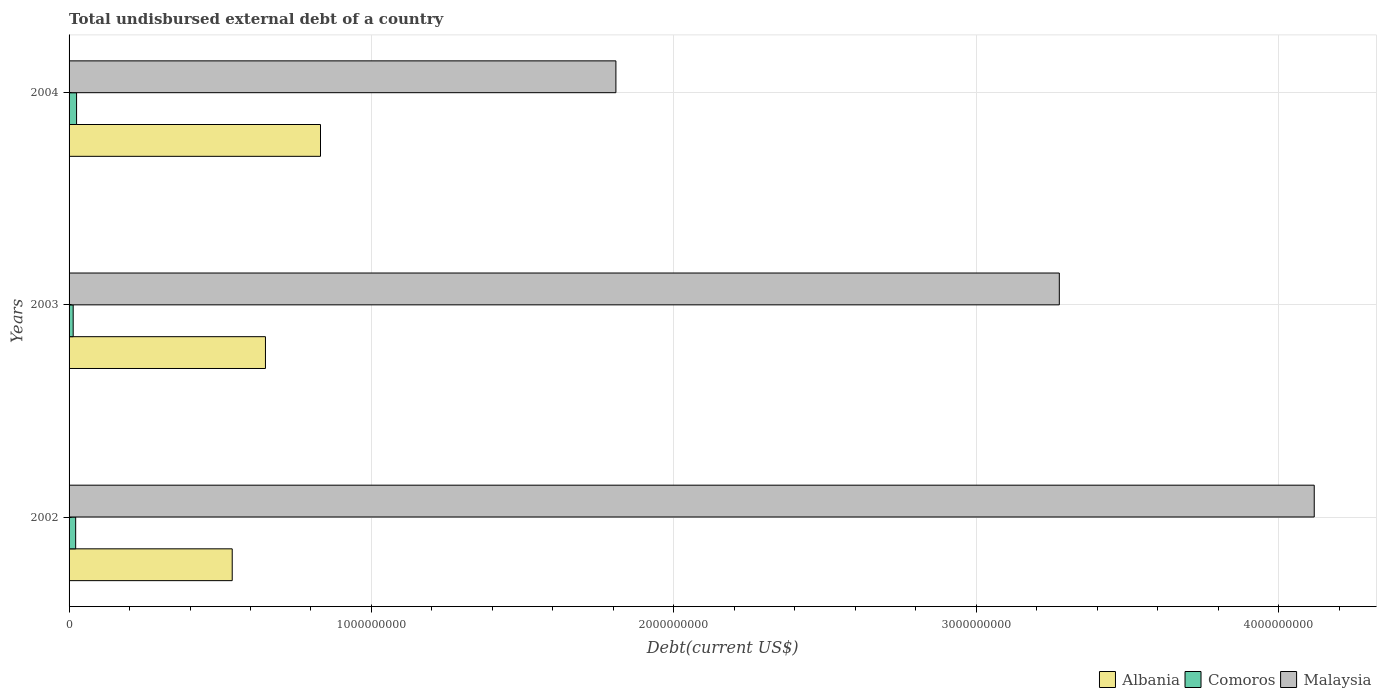How many different coloured bars are there?
Your answer should be very brief. 3. Are the number of bars on each tick of the Y-axis equal?
Your answer should be compact. Yes. How many bars are there on the 3rd tick from the top?
Make the answer very short. 3. How many bars are there on the 2nd tick from the bottom?
Give a very brief answer. 3. What is the total undisbursed external debt in Malaysia in 2002?
Your response must be concise. 4.12e+09. Across all years, what is the maximum total undisbursed external debt in Albania?
Provide a succinct answer. 8.31e+08. Across all years, what is the minimum total undisbursed external debt in Comoros?
Offer a very short reply. 1.36e+07. In which year was the total undisbursed external debt in Malaysia maximum?
Give a very brief answer. 2002. What is the total total undisbursed external debt in Albania in the graph?
Provide a succinct answer. 2.02e+09. What is the difference between the total undisbursed external debt in Comoros in 2003 and that in 2004?
Offer a very short reply. -1.12e+07. What is the difference between the total undisbursed external debt in Comoros in 2004 and the total undisbursed external debt in Malaysia in 2002?
Offer a terse response. -4.09e+09. What is the average total undisbursed external debt in Malaysia per year?
Your response must be concise. 3.07e+09. In the year 2003, what is the difference between the total undisbursed external debt in Malaysia and total undisbursed external debt in Comoros?
Offer a terse response. 3.26e+09. In how many years, is the total undisbursed external debt in Malaysia greater than 2800000000 US$?
Give a very brief answer. 2. What is the ratio of the total undisbursed external debt in Comoros in 2003 to that in 2004?
Provide a short and direct response. 0.55. Is the difference between the total undisbursed external debt in Malaysia in 2002 and 2003 greater than the difference between the total undisbursed external debt in Comoros in 2002 and 2003?
Give a very brief answer. Yes. What is the difference between the highest and the second highest total undisbursed external debt in Comoros?
Give a very brief answer. 3.01e+06. What is the difference between the highest and the lowest total undisbursed external debt in Comoros?
Keep it short and to the point. 1.12e+07. In how many years, is the total undisbursed external debt in Albania greater than the average total undisbursed external debt in Albania taken over all years?
Your response must be concise. 1. What does the 2nd bar from the top in 2003 represents?
Keep it short and to the point. Comoros. What does the 1st bar from the bottom in 2004 represents?
Provide a succinct answer. Albania. How many bars are there?
Provide a short and direct response. 9. Are all the bars in the graph horizontal?
Offer a terse response. Yes. How many years are there in the graph?
Give a very brief answer. 3. What is the difference between two consecutive major ticks on the X-axis?
Offer a terse response. 1.00e+09. Are the values on the major ticks of X-axis written in scientific E-notation?
Provide a short and direct response. No. Does the graph contain grids?
Make the answer very short. Yes. Where does the legend appear in the graph?
Your answer should be compact. Bottom right. What is the title of the graph?
Provide a succinct answer. Total undisbursed external debt of a country. What is the label or title of the X-axis?
Provide a succinct answer. Debt(current US$). What is the Debt(current US$) in Albania in 2002?
Your answer should be very brief. 5.40e+08. What is the Debt(current US$) of Comoros in 2002?
Ensure brevity in your answer.  2.18e+07. What is the Debt(current US$) of Malaysia in 2002?
Ensure brevity in your answer.  4.12e+09. What is the Debt(current US$) of Albania in 2003?
Give a very brief answer. 6.49e+08. What is the Debt(current US$) in Comoros in 2003?
Ensure brevity in your answer.  1.36e+07. What is the Debt(current US$) in Malaysia in 2003?
Your answer should be compact. 3.27e+09. What is the Debt(current US$) in Albania in 2004?
Offer a very short reply. 8.31e+08. What is the Debt(current US$) of Comoros in 2004?
Offer a very short reply. 2.48e+07. What is the Debt(current US$) of Malaysia in 2004?
Offer a very short reply. 1.81e+09. Across all years, what is the maximum Debt(current US$) in Albania?
Your response must be concise. 8.31e+08. Across all years, what is the maximum Debt(current US$) in Comoros?
Your answer should be very brief. 2.48e+07. Across all years, what is the maximum Debt(current US$) in Malaysia?
Make the answer very short. 4.12e+09. Across all years, what is the minimum Debt(current US$) of Albania?
Your response must be concise. 5.40e+08. Across all years, what is the minimum Debt(current US$) in Comoros?
Your answer should be very brief. 1.36e+07. Across all years, what is the minimum Debt(current US$) of Malaysia?
Your answer should be very brief. 1.81e+09. What is the total Debt(current US$) of Albania in the graph?
Provide a short and direct response. 2.02e+09. What is the total Debt(current US$) of Comoros in the graph?
Keep it short and to the point. 6.03e+07. What is the total Debt(current US$) in Malaysia in the graph?
Your answer should be very brief. 9.20e+09. What is the difference between the Debt(current US$) in Albania in 2002 and that in 2003?
Provide a succinct answer. -1.10e+08. What is the difference between the Debt(current US$) of Comoros in 2002 and that in 2003?
Your answer should be compact. 8.18e+06. What is the difference between the Debt(current US$) of Malaysia in 2002 and that in 2003?
Offer a terse response. 8.43e+08. What is the difference between the Debt(current US$) in Albania in 2002 and that in 2004?
Provide a succinct answer. -2.92e+08. What is the difference between the Debt(current US$) of Comoros in 2002 and that in 2004?
Make the answer very short. -3.01e+06. What is the difference between the Debt(current US$) of Malaysia in 2002 and that in 2004?
Your response must be concise. 2.31e+09. What is the difference between the Debt(current US$) of Albania in 2003 and that in 2004?
Provide a short and direct response. -1.82e+08. What is the difference between the Debt(current US$) in Comoros in 2003 and that in 2004?
Make the answer very short. -1.12e+07. What is the difference between the Debt(current US$) of Malaysia in 2003 and that in 2004?
Give a very brief answer. 1.47e+09. What is the difference between the Debt(current US$) in Albania in 2002 and the Debt(current US$) in Comoros in 2003?
Offer a very short reply. 5.26e+08. What is the difference between the Debt(current US$) of Albania in 2002 and the Debt(current US$) of Malaysia in 2003?
Offer a terse response. -2.74e+09. What is the difference between the Debt(current US$) in Comoros in 2002 and the Debt(current US$) in Malaysia in 2003?
Keep it short and to the point. -3.25e+09. What is the difference between the Debt(current US$) of Albania in 2002 and the Debt(current US$) of Comoros in 2004?
Ensure brevity in your answer.  5.15e+08. What is the difference between the Debt(current US$) in Albania in 2002 and the Debt(current US$) in Malaysia in 2004?
Offer a very short reply. -1.27e+09. What is the difference between the Debt(current US$) of Comoros in 2002 and the Debt(current US$) of Malaysia in 2004?
Ensure brevity in your answer.  -1.79e+09. What is the difference between the Debt(current US$) in Albania in 2003 and the Debt(current US$) in Comoros in 2004?
Provide a succinct answer. 6.25e+08. What is the difference between the Debt(current US$) in Albania in 2003 and the Debt(current US$) in Malaysia in 2004?
Provide a succinct answer. -1.16e+09. What is the difference between the Debt(current US$) in Comoros in 2003 and the Debt(current US$) in Malaysia in 2004?
Provide a short and direct response. -1.79e+09. What is the average Debt(current US$) in Albania per year?
Keep it short and to the point. 6.73e+08. What is the average Debt(current US$) in Comoros per year?
Your response must be concise. 2.01e+07. What is the average Debt(current US$) in Malaysia per year?
Make the answer very short. 3.07e+09. In the year 2002, what is the difference between the Debt(current US$) of Albania and Debt(current US$) of Comoros?
Offer a very short reply. 5.18e+08. In the year 2002, what is the difference between the Debt(current US$) in Albania and Debt(current US$) in Malaysia?
Your answer should be very brief. -3.58e+09. In the year 2002, what is the difference between the Debt(current US$) of Comoros and Debt(current US$) of Malaysia?
Your response must be concise. -4.10e+09. In the year 2003, what is the difference between the Debt(current US$) of Albania and Debt(current US$) of Comoros?
Ensure brevity in your answer.  6.36e+08. In the year 2003, what is the difference between the Debt(current US$) in Albania and Debt(current US$) in Malaysia?
Offer a very short reply. -2.63e+09. In the year 2003, what is the difference between the Debt(current US$) in Comoros and Debt(current US$) in Malaysia?
Ensure brevity in your answer.  -3.26e+09. In the year 2004, what is the difference between the Debt(current US$) in Albania and Debt(current US$) in Comoros?
Your answer should be compact. 8.07e+08. In the year 2004, what is the difference between the Debt(current US$) of Albania and Debt(current US$) of Malaysia?
Provide a short and direct response. -9.77e+08. In the year 2004, what is the difference between the Debt(current US$) in Comoros and Debt(current US$) in Malaysia?
Keep it short and to the point. -1.78e+09. What is the ratio of the Debt(current US$) of Albania in 2002 to that in 2003?
Your response must be concise. 0.83. What is the ratio of the Debt(current US$) of Comoros in 2002 to that in 2003?
Offer a terse response. 1.6. What is the ratio of the Debt(current US$) of Malaysia in 2002 to that in 2003?
Give a very brief answer. 1.26. What is the ratio of the Debt(current US$) of Albania in 2002 to that in 2004?
Ensure brevity in your answer.  0.65. What is the ratio of the Debt(current US$) of Comoros in 2002 to that in 2004?
Make the answer very short. 0.88. What is the ratio of the Debt(current US$) in Malaysia in 2002 to that in 2004?
Your response must be concise. 2.28. What is the ratio of the Debt(current US$) of Albania in 2003 to that in 2004?
Offer a terse response. 0.78. What is the ratio of the Debt(current US$) in Comoros in 2003 to that in 2004?
Your response must be concise. 0.55. What is the ratio of the Debt(current US$) of Malaysia in 2003 to that in 2004?
Your response must be concise. 1.81. What is the difference between the highest and the second highest Debt(current US$) of Albania?
Provide a short and direct response. 1.82e+08. What is the difference between the highest and the second highest Debt(current US$) of Comoros?
Make the answer very short. 3.01e+06. What is the difference between the highest and the second highest Debt(current US$) in Malaysia?
Offer a very short reply. 8.43e+08. What is the difference between the highest and the lowest Debt(current US$) of Albania?
Give a very brief answer. 2.92e+08. What is the difference between the highest and the lowest Debt(current US$) in Comoros?
Your answer should be compact. 1.12e+07. What is the difference between the highest and the lowest Debt(current US$) of Malaysia?
Offer a very short reply. 2.31e+09. 